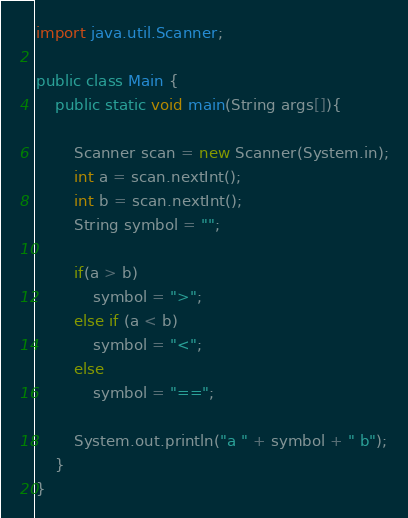Convert code to text. <code><loc_0><loc_0><loc_500><loc_500><_Java_>import java.util.Scanner;

public class Main {
    public static void main(String args[]){

        Scanner scan = new Scanner(System.in);
        int a = scan.nextInt();
        int b = scan.nextInt();
        String symbol = "";

        if(a > b)
            symbol = ">";
        else if (a < b)
            symbol = "<";
        else
            symbol = "==";

        System.out.println("a " + symbol + " b");
    }
}

</code> 